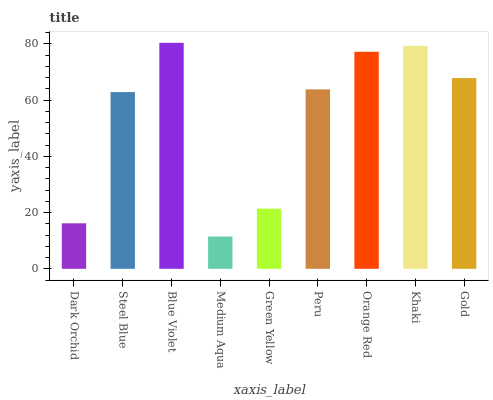Is Steel Blue the minimum?
Answer yes or no. No. Is Steel Blue the maximum?
Answer yes or no. No. Is Steel Blue greater than Dark Orchid?
Answer yes or no. Yes. Is Dark Orchid less than Steel Blue?
Answer yes or no. Yes. Is Dark Orchid greater than Steel Blue?
Answer yes or no. No. Is Steel Blue less than Dark Orchid?
Answer yes or no. No. Is Peru the high median?
Answer yes or no. Yes. Is Peru the low median?
Answer yes or no. Yes. Is Medium Aqua the high median?
Answer yes or no. No. Is Medium Aqua the low median?
Answer yes or no. No. 